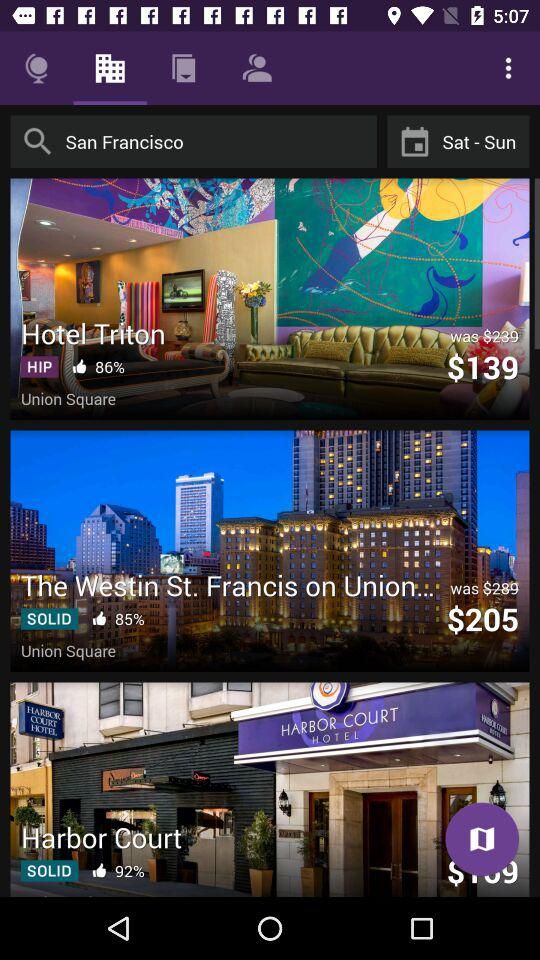What is the location? The location is San Francisco. 